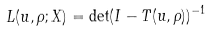<formula> <loc_0><loc_0><loc_500><loc_500>L ( { u } , \rho ; X ) = \det ( I - T ( { u } , \rho ) ) ^ { - 1 }</formula> 